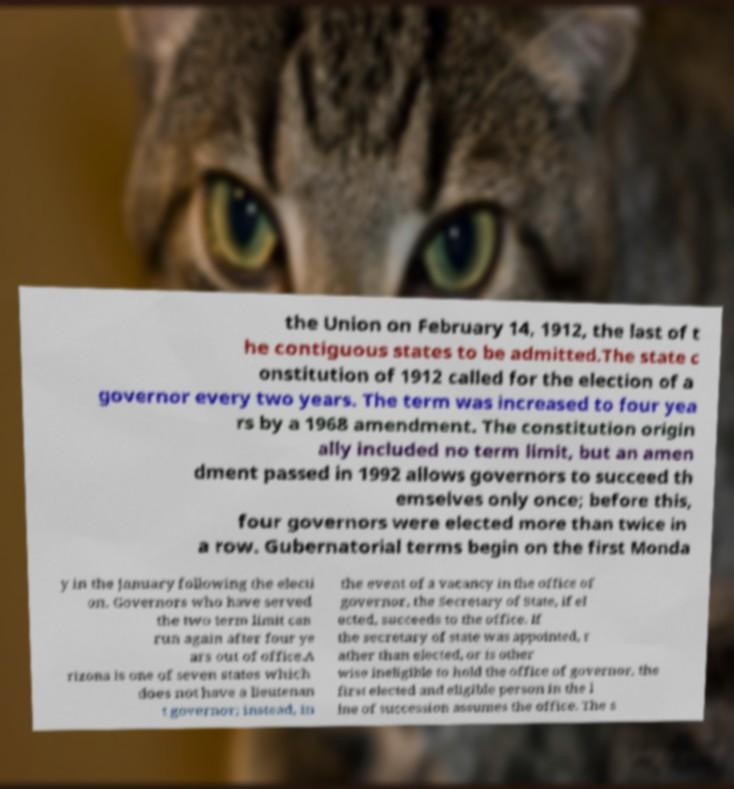Could you extract and type out the text from this image? the Union on February 14, 1912, the last of t he contiguous states to be admitted.The state c onstitution of 1912 called for the election of a governor every two years. The term was increased to four yea rs by a 1968 amendment. The constitution origin ally included no term limit, but an amen dment passed in 1992 allows governors to succeed th emselves only once; before this, four governors were elected more than twice in a row. Gubernatorial terms begin on the first Monda y in the January following the electi on. Governors who have served the two term limit can run again after four ye ars out of office.A rizona is one of seven states which does not have a lieutenan t governor; instead, in the event of a vacancy in the office of governor, the Secretary of State, if el ected, succeeds to the office. If the secretary of state was appointed, r ather than elected, or is other wise ineligible to hold the office of governor, the first elected and eligible person in the l ine of succession assumes the office. The s 